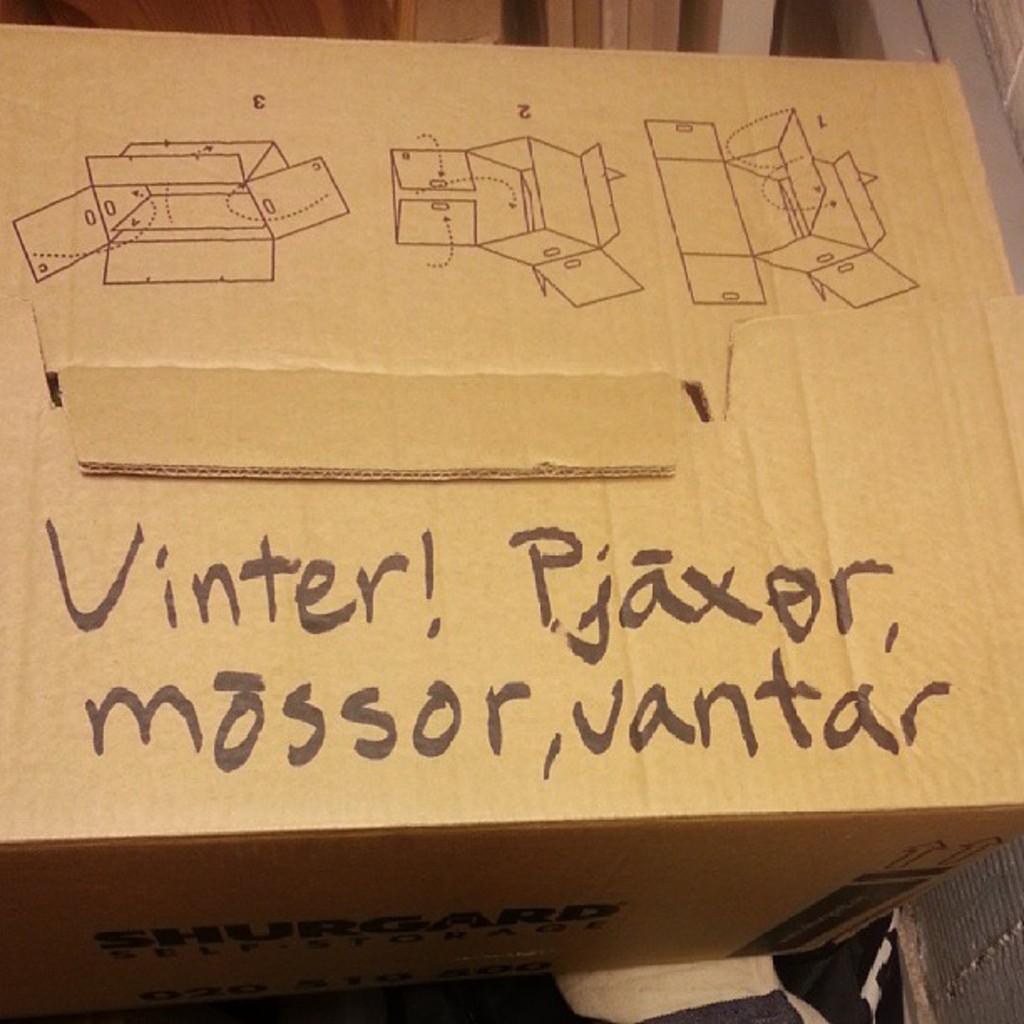What is written on the box?
Give a very brief answer. Vinter! pjaxor, mossor, vantar. What does the box say?
Ensure brevity in your answer.  Vinter! pjaxor mossor, vantar. 